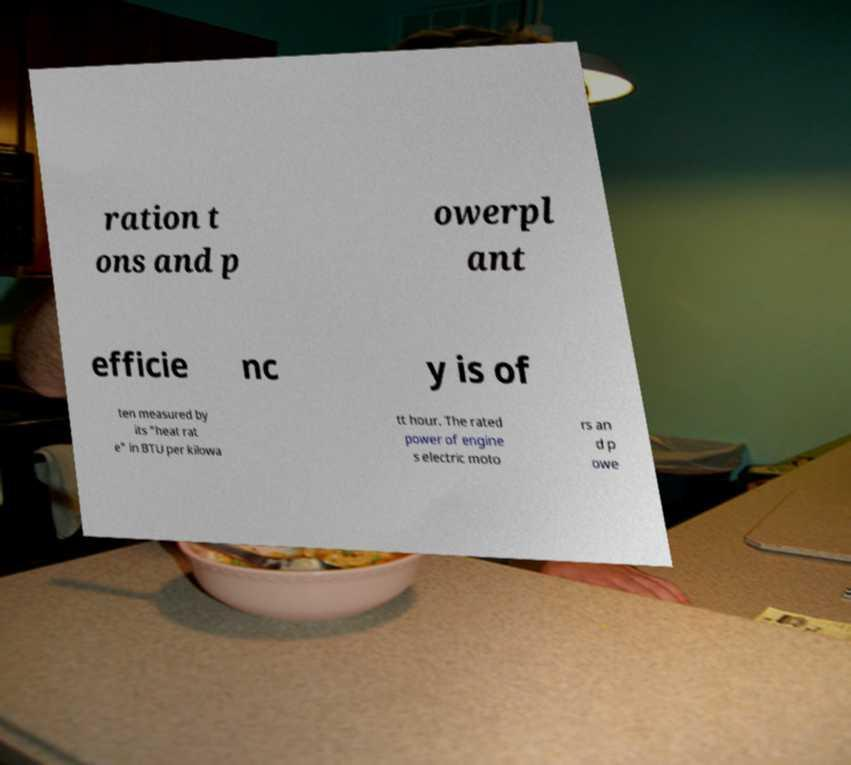Could you extract and type out the text from this image? ration t ons and p owerpl ant efficie nc y is of ten measured by its "heat rat e" in BTU per kilowa tt hour. The rated power of engine s electric moto rs an d p owe 